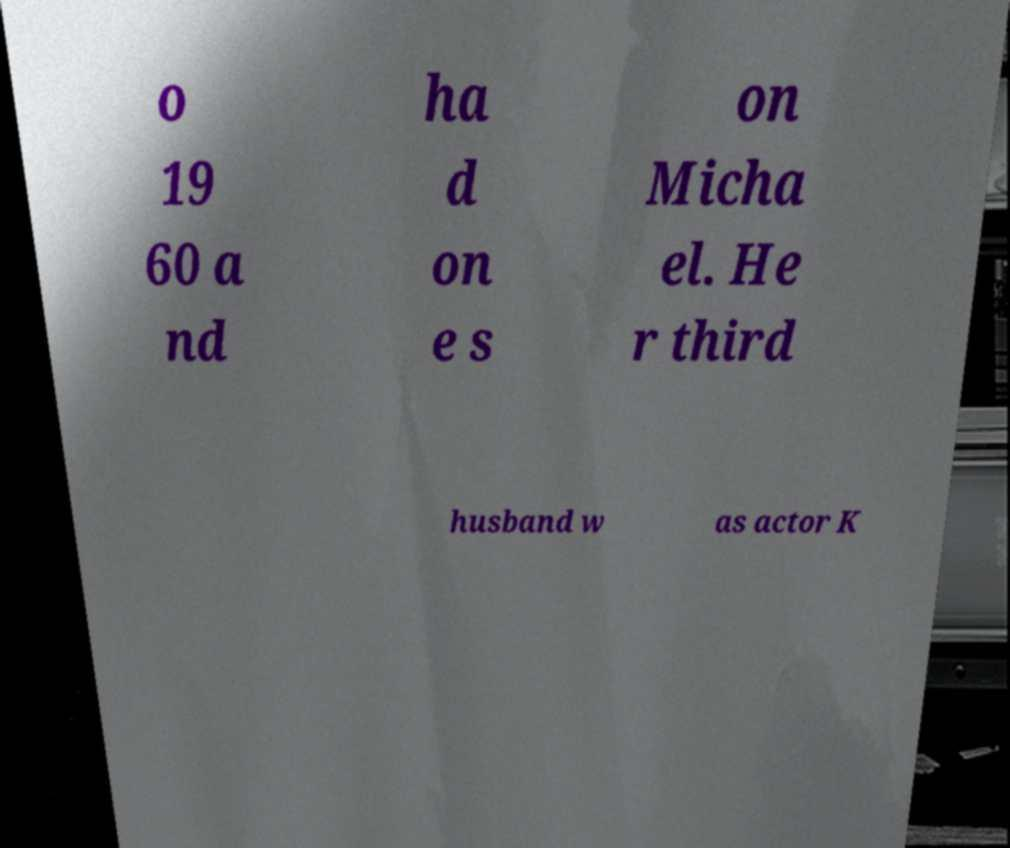Can you read and provide the text displayed in the image?This photo seems to have some interesting text. Can you extract and type it out for me? o 19 60 a nd ha d on e s on Micha el. He r third husband w as actor K 